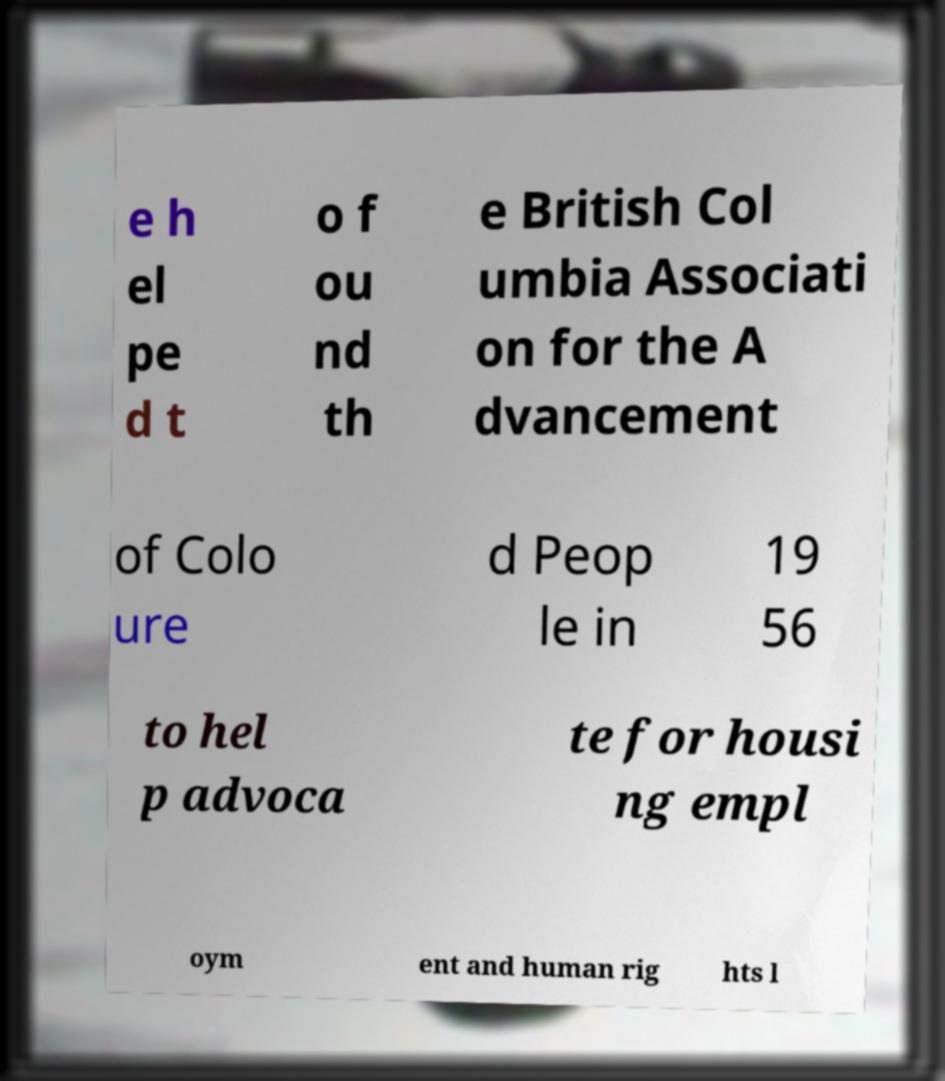Could you assist in decoding the text presented in this image and type it out clearly? e h el pe d t o f ou nd th e British Col umbia Associati on for the A dvancement of Colo ure d Peop le in 19 56 to hel p advoca te for housi ng empl oym ent and human rig hts l 